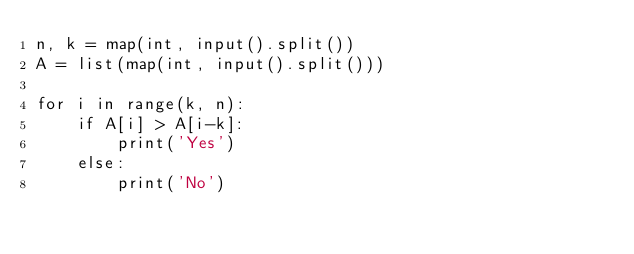<code> <loc_0><loc_0><loc_500><loc_500><_Python_>n, k = map(int, input().split())
A = list(map(int, input().split()))

for i in range(k, n):
    if A[i] > A[i-k]:
        print('Yes')
    else:
        print('No')</code> 